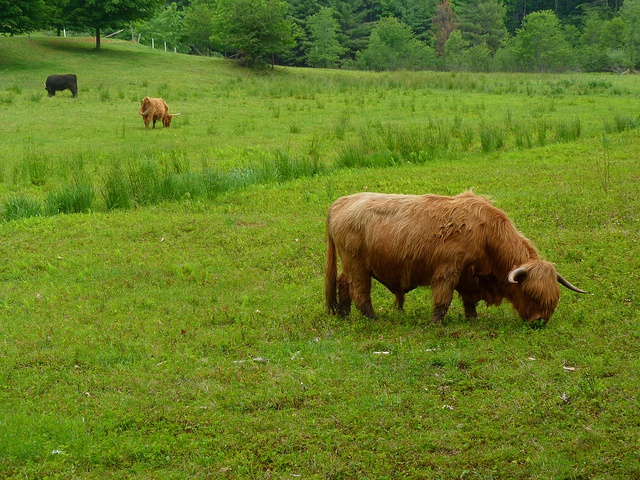Describe the objects in this image and their specific colors. I can see cow in darkgreen, black, maroon, and olive tones, cow in darkgreen, olive, maroon, and tan tones, and cow in darkgreen, black, and gray tones in this image. 